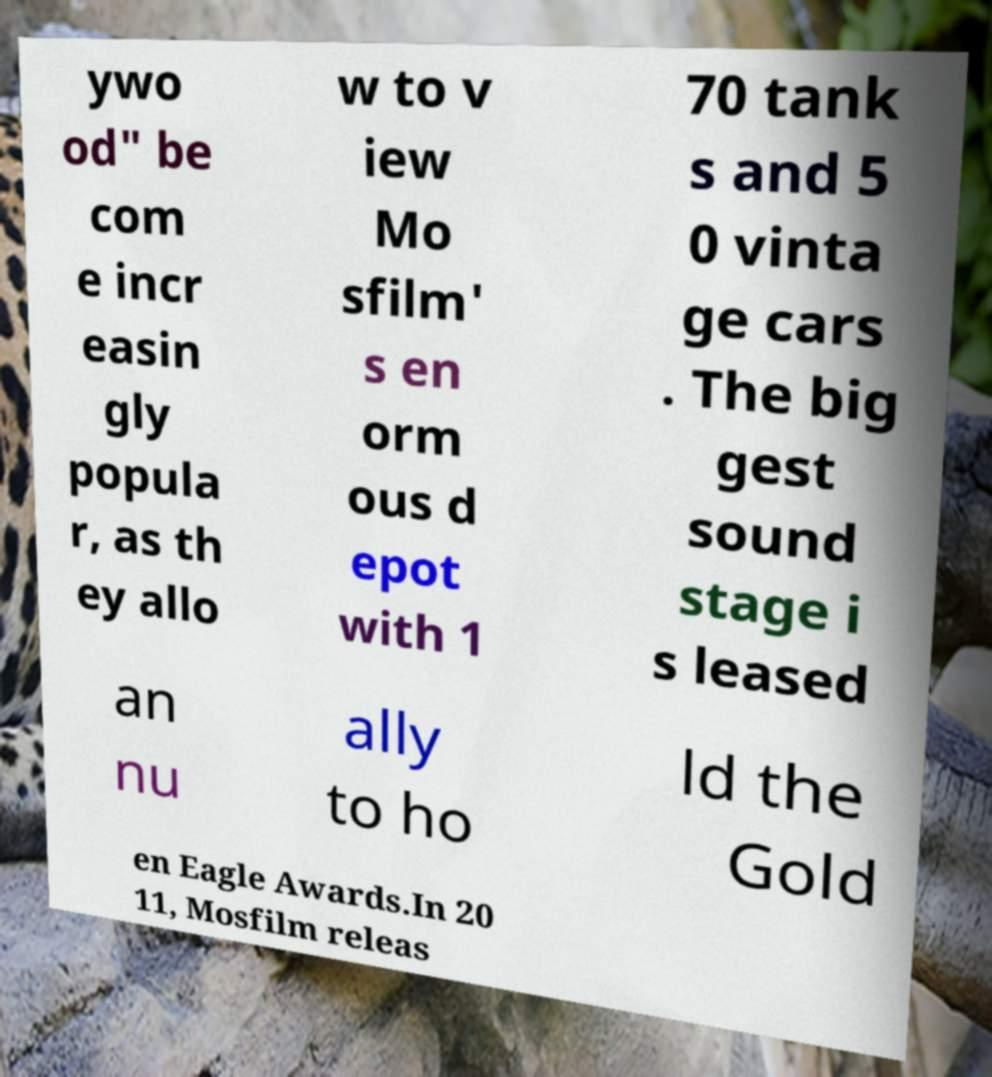I need the written content from this picture converted into text. Can you do that? ywo od" be com e incr easin gly popula r, as th ey allo w to v iew Mo sfilm' s en orm ous d epot with 1 70 tank s and 5 0 vinta ge cars . The big gest sound stage i s leased an nu ally to ho ld the Gold en Eagle Awards.In 20 11, Mosfilm releas 